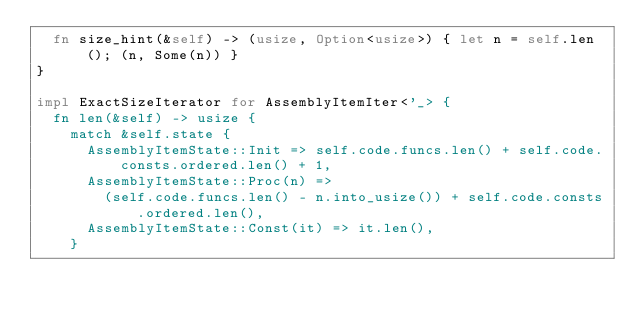<code> <loc_0><loc_0><loc_500><loc_500><_Rust_>  fn size_hint(&self) -> (usize, Option<usize>) { let n = self.len(); (n, Some(n)) }
}

impl ExactSizeIterator for AssemblyItemIter<'_> {
  fn len(&self) -> usize {
    match &self.state {
      AssemblyItemState::Init => self.code.funcs.len() + self.code.consts.ordered.len() + 1,
      AssemblyItemState::Proc(n) =>
        (self.code.funcs.len() - n.into_usize()) + self.code.consts.ordered.len(),
      AssemblyItemState::Const(it) => it.len(),
    }</code> 